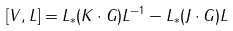<formula> <loc_0><loc_0><loc_500><loc_500>[ V , L ] = L _ { * } ( K \cdot G ) L ^ { - 1 } - L _ { * } ( J \cdot G ) L</formula> 